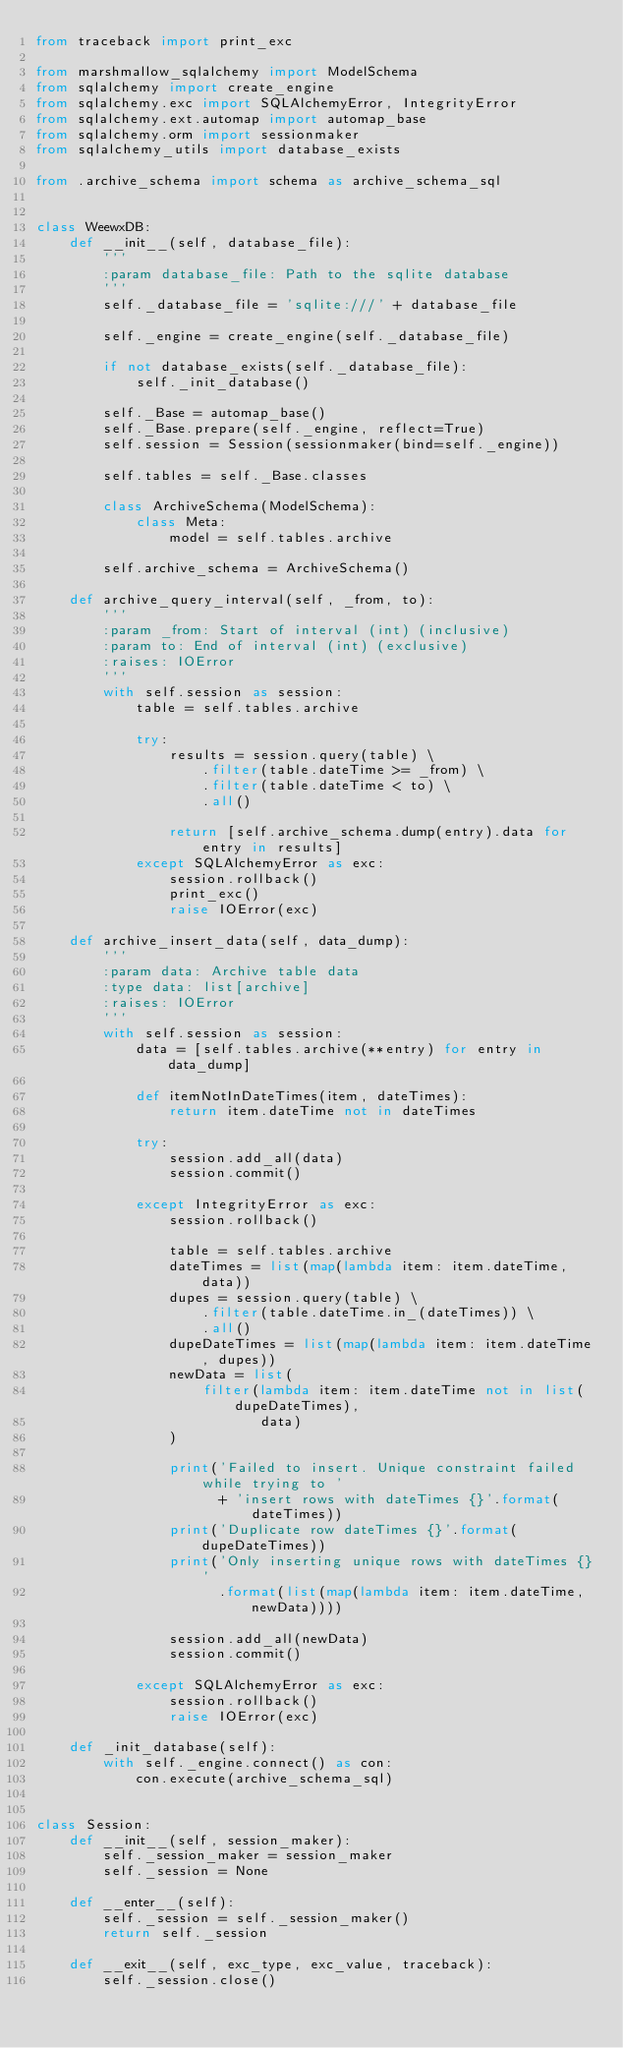Convert code to text. <code><loc_0><loc_0><loc_500><loc_500><_Python_>from traceback import print_exc

from marshmallow_sqlalchemy import ModelSchema
from sqlalchemy import create_engine
from sqlalchemy.exc import SQLAlchemyError, IntegrityError
from sqlalchemy.ext.automap import automap_base
from sqlalchemy.orm import sessionmaker
from sqlalchemy_utils import database_exists

from .archive_schema import schema as archive_schema_sql


class WeewxDB:
    def __init__(self, database_file):
        '''
        :param database_file: Path to the sqlite database
        '''
        self._database_file = 'sqlite:///' + database_file

        self._engine = create_engine(self._database_file)

        if not database_exists(self._database_file):
            self._init_database()

        self._Base = automap_base()
        self._Base.prepare(self._engine, reflect=True)
        self.session = Session(sessionmaker(bind=self._engine))

        self.tables = self._Base.classes

        class ArchiveSchema(ModelSchema):
            class Meta:
                model = self.tables.archive

        self.archive_schema = ArchiveSchema()

    def archive_query_interval(self, _from, to):
        '''
        :param _from: Start of interval (int) (inclusive)
        :param to: End of interval (int) (exclusive)
        :raises: IOError
        '''
        with self.session as session:
            table = self.tables.archive

            try:
                results = session.query(table) \
                    .filter(table.dateTime >= _from) \
                    .filter(table.dateTime < to) \
                    .all()

                return [self.archive_schema.dump(entry).data for entry in results]
            except SQLAlchemyError as exc:
                session.rollback()
                print_exc()
                raise IOError(exc)

    def archive_insert_data(self, data_dump):
        '''
        :param data: Archive table data
        :type data: list[archive]
        :raises: IOError
        '''
        with self.session as session:
            data = [self.tables.archive(**entry) for entry in data_dump]

            def itemNotInDateTimes(item, dateTimes):
                return item.dateTime not in dateTimes

            try:
                session.add_all(data)
                session.commit()

            except IntegrityError as exc:
                session.rollback()

                table = self.tables.archive
                dateTimes = list(map(lambda item: item.dateTime, data))
                dupes = session.query(table) \
                    .filter(table.dateTime.in_(dateTimes)) \
                    .all()
                dupeDateTimes = list(map(lambda item: item.dateTime, dupes))
                newData = list(
                    filter(lambda item: item.dateTime not in list(dupeDateTimes),
                           data)
                )

                print('Failed to insert. Unique constraint failed while trying to '
                      + 'insert rows with dateTimes {}'.format(dateTimes))
                print('Duplicate row dateTimes {}'.format(dupeDateTimes))
                print('Only inserting unique rows with dateTimes {}'
                      .format(list(map(lambda item: item.dateTime, newData))))

                session.add_all(newData)
                session.commit()

            except SQLAlchemyError as exc:
                session.rollback()
                raise IOError(exc)

    def _init_database(self):
        with self._engine.connect() as con:
            con.execute(archive_schema_sql)


class Session:
    def __init__(self, session_maker):
        self._session_maker = session_maker
        self._session = None

    def __enter__(self):
        self._session = self._session_maker()
        return self._session

    def __exit__(self, exc_type, exc_value, traceback):
        self._session.close()
</code> 